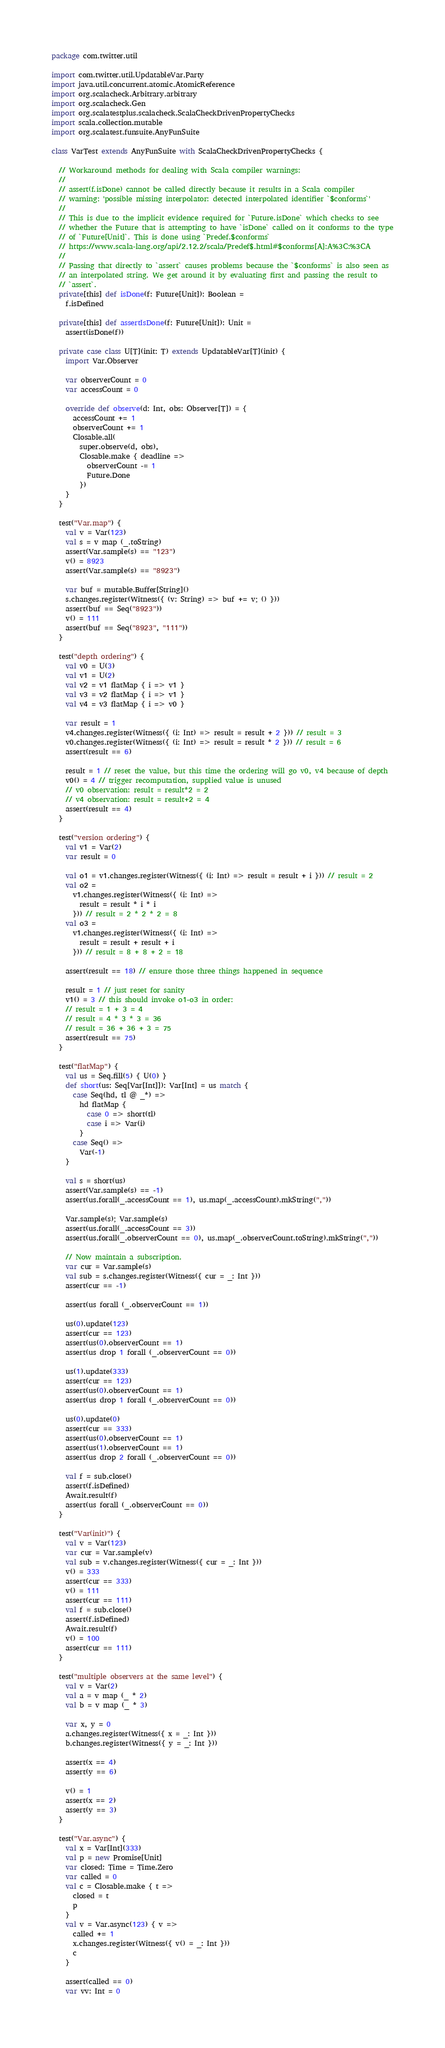<code> <loc_0><loc_0><loc_500><loc_500><_Scala_>package com.twitter.util

import com.twitter.util.UpdatableVar.Party
import java.util.concurrent.atomic.AtomicReference
import org.scalacheck.Arbitrary.arbitrary
import org.scalacheck.Gen
import org.scalatestplus.scalacheck.ScalaCheckDrivenPropertyChecks
import scala.collection.mutable
import org.scalatest.funsuite.AnyFunSuite

class VarTest extends AnyFunSuite with ScalaCheckDrivenPropertyChecks {

  // Workaround methods for dealing with Scala compiler warnings:
  //
  // assert(f.isDone) cannot be called directly because it results in a Scala compiler
  // warning: 'possible missing interpolator: detected interpolated identifier `$conforms`'
  //
  // This is due to the implicit evidence required for `Future.isDone` which checks to see
  // whether the Future that is attempting to have `isDone` called on it conforms to the type
  // of `Future[Unit]`. This is done using `Predef.$conforms`
  // https://www.scala-lang.org/api/2.12.2/scala/Predef$.html#$conforms[A]:A%3C:%3CA
  //
  // Passing that directly to `assert` causes problems because the `$conforms` is also seen as
  // an interpolated string. We get around it by evaluating first and passing the result to
  // `assert`.
  private[this] def isDone(f: Future[Unit]): Boolean =
    f.isDefined

  private[this] def assertIsDone(f: Future[Unit]): Unit =
    assert(isDone(f))

  private case class U[T](init: T) extends UpdatableVar[T](init) {
    import Var.Observer

    var observerCount = 0
    var accessCount = 0

    override def observe(d: Int, obs: Observer[T]) = {
      accessCount += 1
      observerCount += 1
      Closable.all(
        super.observe(d, obs),
        Closable.make { deadline =>
          observerCount -= 1
          Future.Done
        })
    }
  }

  test("Var.map") {
    val v = Var(123)
    val s = v map (_.toString)
    assert(Var.sample(s) == "123")
    v() = 8923
    assert(Var.sample(s) == "8923")

    var buf = mutable.Buffer[String]()
    s.changes.register(Witness({ (v: String) => buf += v; () }))
    assert(buf == Seq("8923"))
    v() = 111
    assert(buf == Seq("8923", "111"))
  }

  test("depth ordering") {
    val v0 = U(3)
    val v1 = U(2)
    val v2 = v1 flatMap { i => v1 }
    val v3 = v2 flatMap { i => v1 }
    val v4 = v3 flatMap { i => v0 }

    var result = 1
    v4.changes.register(Witness({ (i: Int) => result = result + 2 })) // result = 3
    v0.changes.register(Witness({ (i: Int) => result = result * 2 })) // result = 6
    assert(result == 6)

    result = 1 // reset the value, but this time the ordering will go v0, v4 because of depth
    v0() = 4 // trigger recomputation, supplied value is unused
    // v0 observation: result = result*2 = 2
    // v4 observation: result = result+2 = 4
    assert(result == 4)
  }

  test("version ordering") {
    val v1 = Var(2)
    var result = 0

    val o1 = v1.changes.register(Witness({ (i: Int) => result = result + i })) // result = 2
    val o2 =
      v1.changes.register(Witness({ (i: Int) =>
        result = result * i * i
      })) // result = 2 * 2 * 2 = 8
    val o3 =
      v1.changes.register(Witness({ (i: Int) =>
        result = result + result + i
      })) // result = 8 + 8 + 2 = 18

    assert(result == 18) // ensure those three things happened in sequence

    result = 1 // just reset for sanity
    v1() = 3 // this should invoke o1-o3 in order:
    // result = 1 + 3 = 4
    // result = 4 * 3 * 3 = 36
    // result = 36 + 36 + 3 = 75
    assert(result == 75)
  }

  test("flatMap") {
    val us = Seq.fill(5) { U(0) }
    def short(us: Seq[Var[Int]]): Var[Int] = us match {
      case Seq(hd, tl @ _*) =>
        hd flatMap {
          case 0 => short(tl)
          case i => Var(i)
        }
      case Seq() =>
        Var(-1)
    }

    val s = short(us)
    assert(Var.sample(s) == -1)
    assert(us.forall(_.accessCount == 1), us.map(_.accessCount).mkString(","))

    Var.sample(s); Var.sample(s)
    assert(us.forall(_.accessCount == 3))
    assert(us.forall(_.observerCount == 0), us.map(_.observerCount.toString).mkString(","))

    // Now maintain a subscription.
    var cur = Var.sample(s)
    val sub = s.changes.register(Witness({ cur = _: Int }))
    assert(cur == -1)

    assert(us forall (_.observerCount == 1))

    us(0).update(123)
    assert(cur == 123)
    assert(us(0).observerCount == 1)
    assert(us drop 1 forall (_.observerCount == 0))

    us(1).update(333)
    assert(cur == 123)
    assert(us(0).observerCount == 1)
    assert(us drop 1 forall (_.observerCount == 0))

    us(0).update(0)
    assert(cur == 333)
    assert(us(0).observerCount == 1)
    assert(us(1).observerCount == 1)
    assert(us drop 2 forall (_.observerCount == 0))

    val f = sub.close()
    assert(f.isDefined)
    Await.result(f)
    assert(us forall (_.observerCount == 0))
  }

  test("Var(init)") {
    val v = Var(123)
    var cur = Var.sample(v)
    val sub = v.changes.register(Witness({ cur = _: Int }))
    v() = 333
    assert(cur == 333)
    v() = 111
    assert(cur == 111)
    val f = sub.close()
    assert(f.isDefined)
    Await.result(f)
    v() = 100
    assert(cur == 111)
  }

  test("multiple observers at the same level") {
    val v = Var(2)
    val a = v map (_ * 2)
    val b = v map (_ * 3)

    var x, y = 0
    a.changes.register(Witness({ x = _: Int }))
    b.changes.register(Witness({ y = _: Int }))

    assert(x == 4)
    assert(y == 6)

    v() = 1
    assert(x == 2)
    assert(y == 3)
  }

  test("Var.async") {
    val x = Var[Int](333)
    val p = new Promise[Unit]
    var closed: Time = Time.Zero
    var called = 0
    val c = Closable.make { t =>
      closed = t
      p
    }
    val v = Var.async(123) { v =>
      called += 1
      x.changes.register(Witness({ v() = _: Int }))
      c
    }

    assert(called == 0)
    var vv: Int = 0</code> 